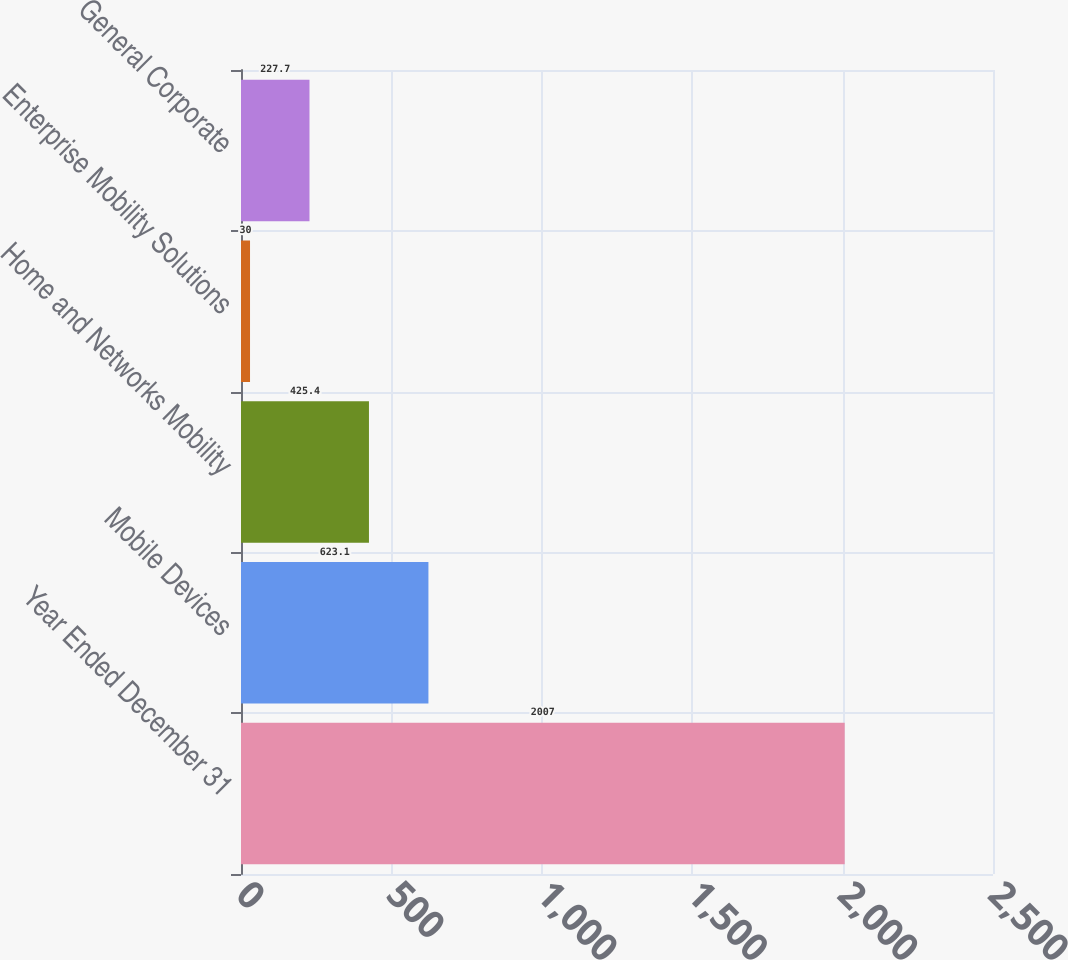<chart> <loc_0><loc_0><loc_500><loc_500><bar_chart><fcel>Year Ended December 31<fcel>Mobile Devices<fcel>Home and Networks Mobility<fcel>Enterprise Mobility Solutions<fcel>General Corporate<nl><fcel>2007<fcel>623.1<fcel>425.4<fcel>30<fcel>227.7<nl></chart> 